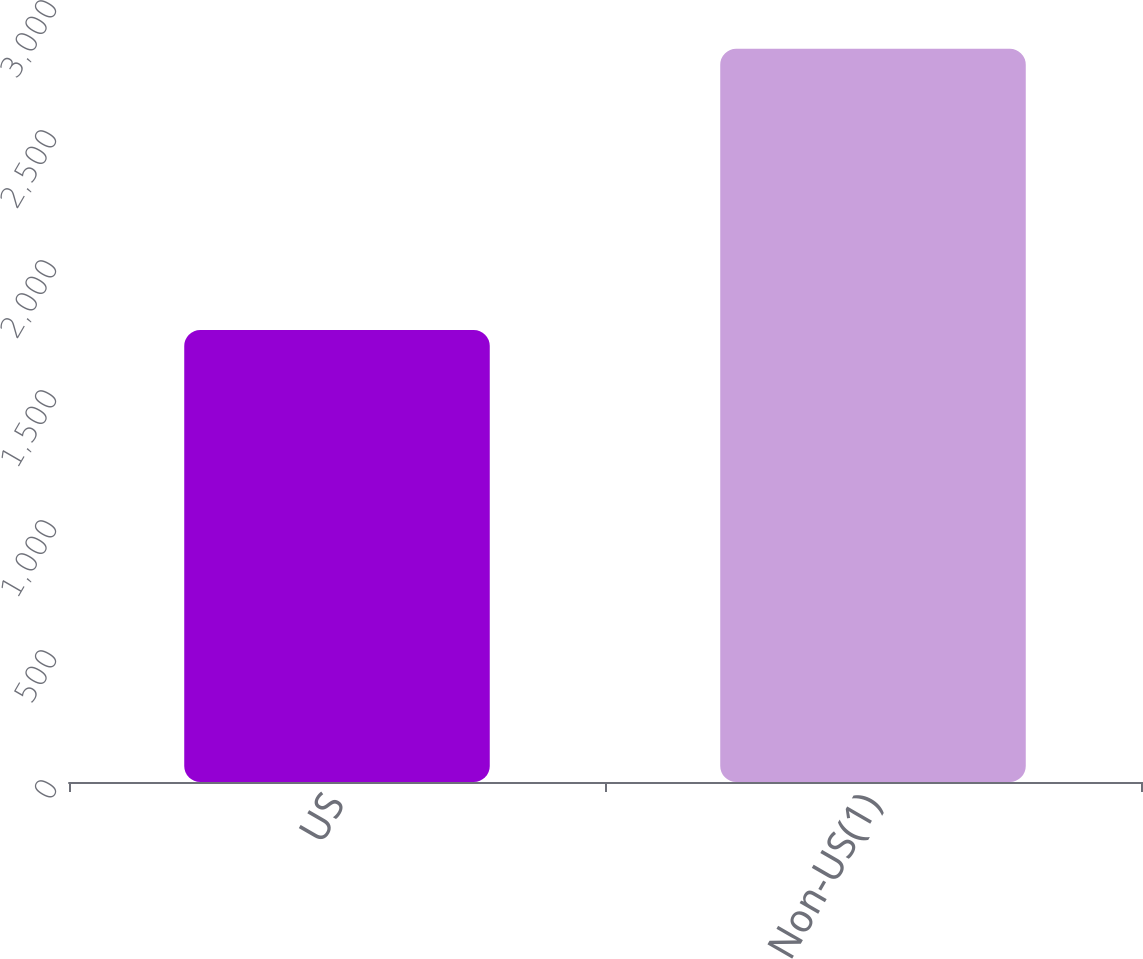<chart> <loc_0><loc_0><loc_500><loc_500><bar_chart><fcel>US<fcel>Non-US(1)<nl><fcel>1738<fcel>2820<nl></chart> 